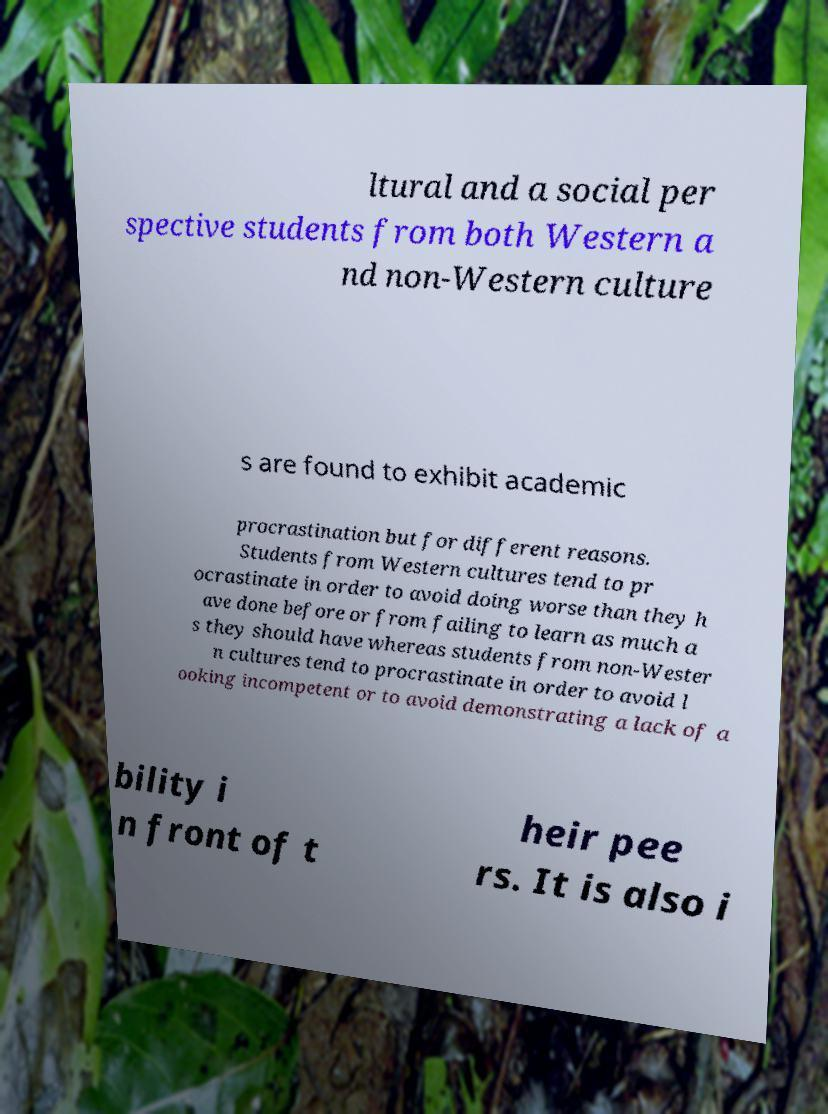I need the written content from this picture converted into text. Can you do that? ltural and a social per spective students from both Western a nd non-Western culture s are found to exhibit academic procrastination but for different reasons. Students from Western cultures tend to pr ocrastinate in order to avoid doing worse than they h ave done before or from failing to learn as much a s they should have whereas students from non-Wester n cultures tend to procrastinate in order to avoid l ooking incompetent or to avoid demonstrating a lack of a bility i n front of t heir pee rs. It is also i 